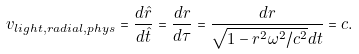Convert formula to latex. <formula><loc_0><loc_0><loc_500><loc_500>v _ { l i g h t , r a d i a l , p h y s } = \frac { d \hat { r } } { d \hat { t } } = \frac { d r } { d \tau } = \frac { d r } { \sqrt { 1 - r ^ { 2 } \omega ^ { 2 } / c ^ { 2 } } d t } = c .</formula> 